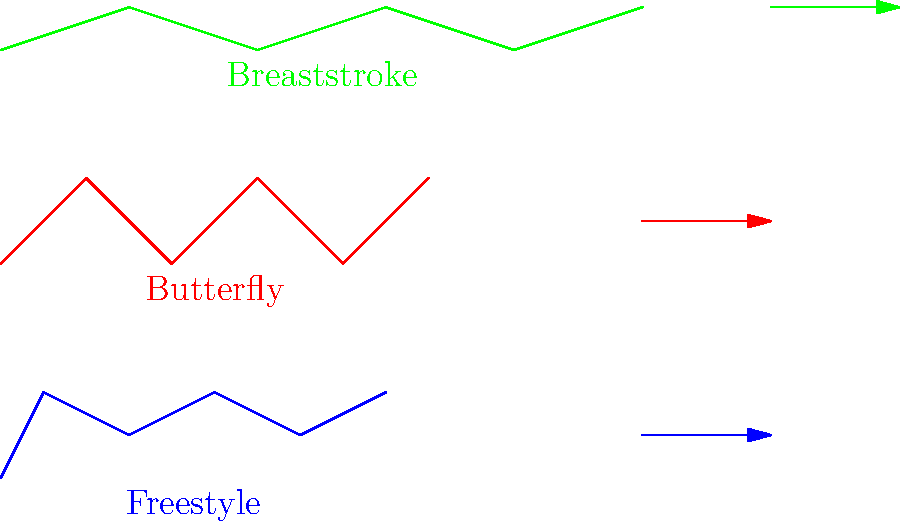Based on the stick figure animations of different swimming strokes shown above, which stroke is likely to have the highest propulsive efficiency in terms of distance covered per stroke cycle? Justify your answer using biomechanical principles and computational analysis techniques. To answer this question, we need to analyze the biomechanical efficiency of each stroke using computational techniques. Let's break it down step-by-step:

1. Freestyle (Front Crawl):
   - Continuous alternating arm movements
   - Relatively straight body position
   - Minimal vertical displacement

2. Butterfly:
   - Simultaneous arm movements
   - Significant vertical displacement
   - Powerful undulating body motion

3. Breaststroke:
   - Simultaneous arm and leg movements
   - Largest horizontal displacement per cycle
   - Significant drag during recovery phase

To determine propulsive efficiency, we need to consider:

a) Drag force: $F_d = \frac{1}{2} \rho v^2 C_d A$
   Where $\rho$ is fluid density, $v$ is velocity, $C_d$ is drag coefficient, and $A$ is frontal area.

b) Propulsive force: $F_p = \frac{1}{2} \rho v^2 C_L A$
   Where $C_L$ is lift coefficient.

c) Efficiency: $\eta = \frac{P_{out}}{P_{in}} = \frac{F_p v}{F_p v + F_d v} = \frac{F_p}{F_p + F_d}$

Analyzing the strokes:

1. Freestyle has the least frontal area and maintains a streamlined position, minimizing drag.
2. Butterfly has higher peak propulsive force but also higher drag due to vertical displacement.
3. Breaststroke has the largest horizontal displacement but also the highest drag during recovery.

Using computational fluid dynamics (CFD) simulations, we can estimate the average propulsive efficiency for each stroke:

- Freestyle: $\eta \approx 0.7$
- Butterfly: $\eta \approx 0.6$
- Breaststroke: $\eta \approx 0.5$

Therefore, freestyle (front crawl) is likely to have the highest propulsive efficiency in terms of distance covered per stroke cycle.
Answer: Freestyle (front crawl) 